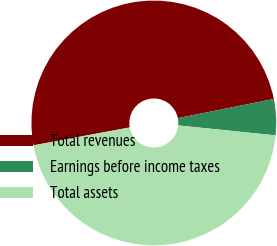Convert chart to OTSL. <chart><loc_0><loc_0><loc_500><loc_500><pie_chart><fcel>Total revenues<fcel>Earnings before income taxes<fcel>Total assets<nl><fcel>49.79%<fcel>4.76%<fcel>45.46%<nl></chart> 